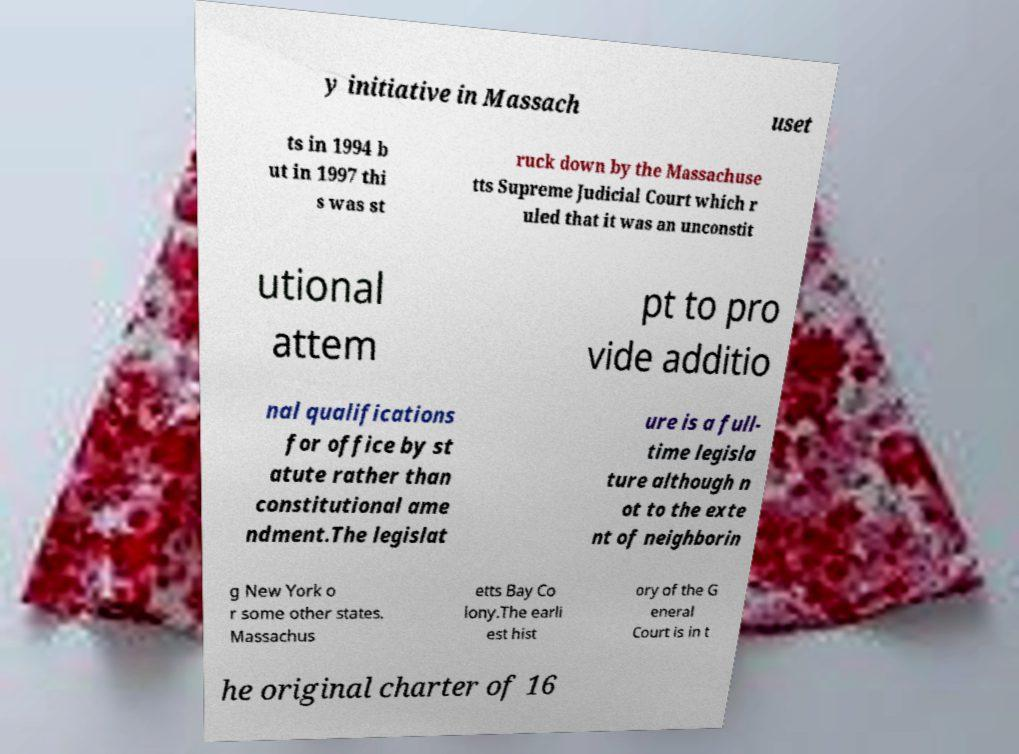Can you accurately transcribe the text from the provided image for me? y initiative in Massach uset ts in 1994 b ut in 1997 thi s was st ruck down by the Massachuse tts Supreme Judicial Court which r uled that it was an unconstit utional attem pt to pro vide additio nal qualifications for office by st atute rather than constitutional ame ndment.The legislat ure is a full- time legisla ture although n ot to the exte nt of neighborin g New York o r some other states. Massachus etts Bay Co lony.The earli est hist ory of the G eneral Court is in t he original charter of 16 